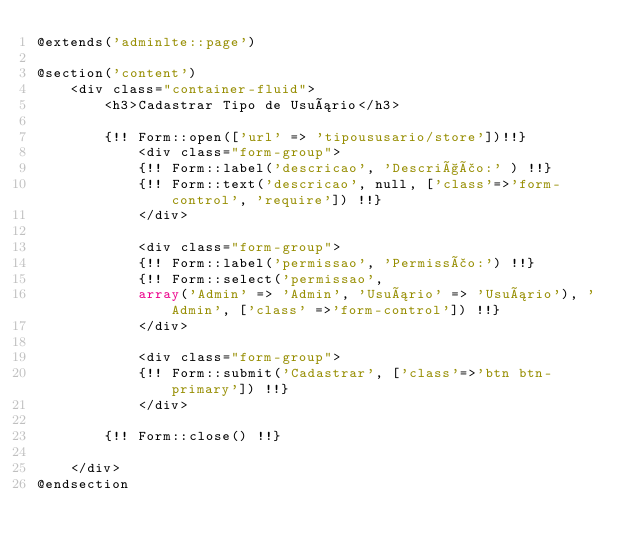<code> <loc_0><loc_0><loc_500><loc_500><_PHP_>@extends('adminlte::page')

@section('content')
    <div class="container-fluid">
        <h3>Cadastrar Tipo de Usuário</h3>

        {!! Form::open(['url' => 'tipoususario/store'])!!}
            <div class="form-group">
            {!! Form::label('descricao', 'Descrição:' ) !!}
            {!! Form::text('descricao', null, ['class'=>'form-control', 'require']) !!}
            </div>

            <div class="form-group">
            {!! Form::label('permissao', 'Permissão:') !!}
            {!! Form::select('permissao', 
            array('Admin' => 'Admin', 'Usuário' => 'Usuário'), 'Admin', ['class' =>'form-control']) !!}
            </div>

            <div class="form-group">
            {!! Form::submit('Cadastrar', ['class'=>'btn btn-primary']) !!}
            </div>

        {!! Form::close() !!}

    </div>
@endsection</code> 